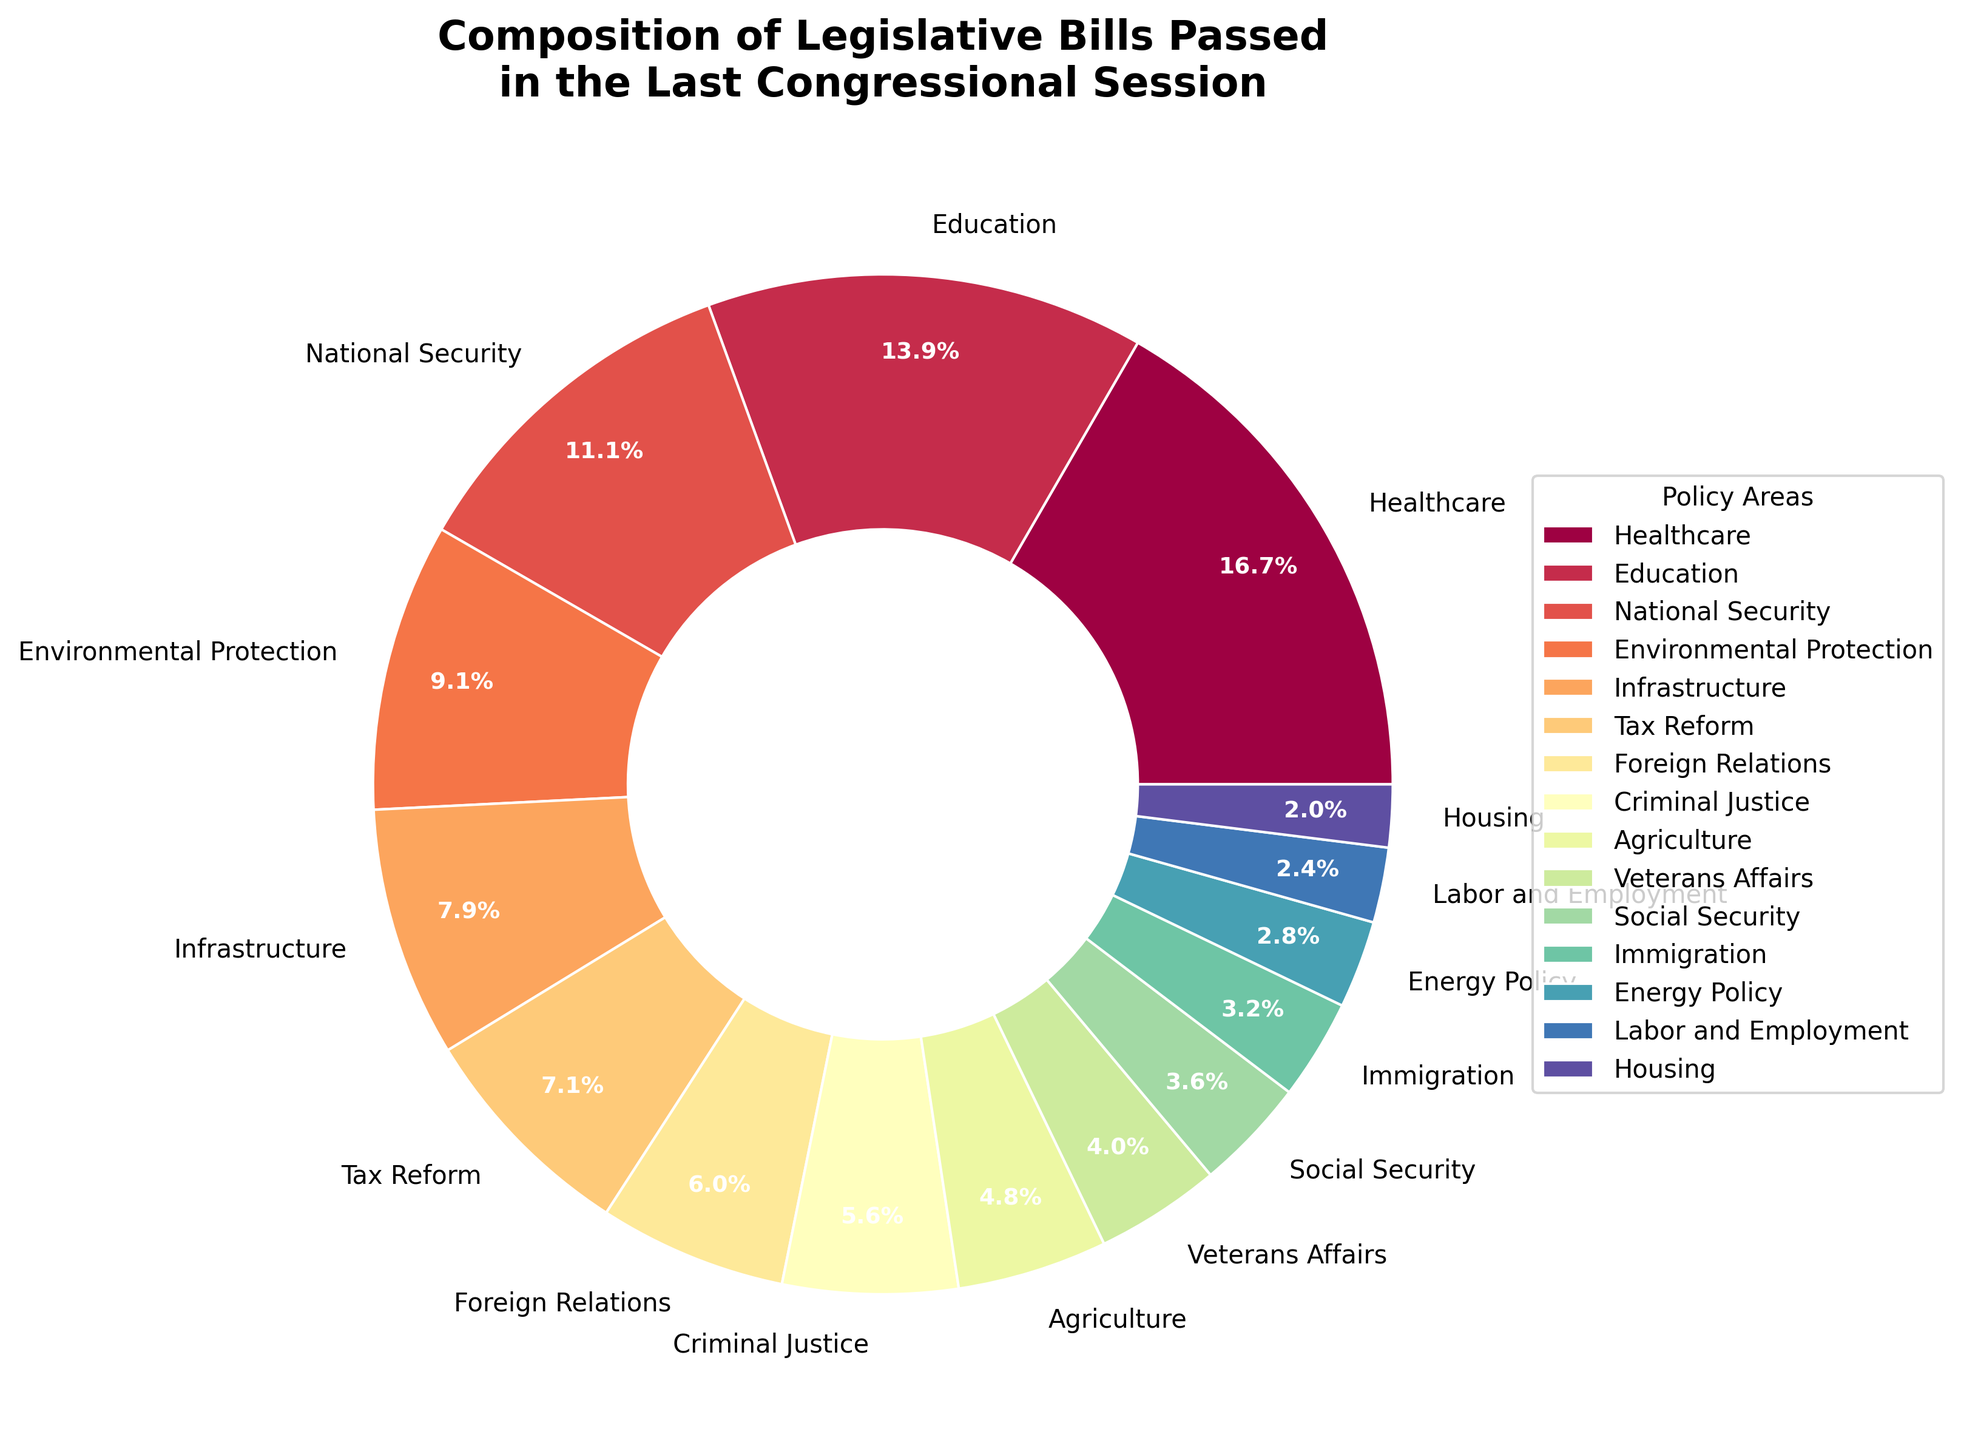What percentage of bills passed pertained to Healthcare? The slice labeled "Healthcare" on the pie chart indicates the percentage of bills related to this policy area.
Answer: 19.0% How many policy areas constitute more than 10% of the total bills passed? To identify this, look at the pie slices that represent more than 10% of the total pie. "Healthcare" (19.0%), "Education" (15.8%), and "National Security" (12.6%) make the cut.
Answer: 3 Which policy area had a higher percentage of bills passed: Environmental Protection or Infrastructure? Compare the percentages shown on the pie slices for "Environmental Protection" and "Infrastructure". "Environmental Protection" is 10.4%, while "Infrastructure" is 9.0%.
Answer: Environmental Protection What is the combined percentage of bills passed in the areas of Tax Reform and Foreign Relations? Add the percentages for "Tax Reform" (8.1%) and "Foreign Relations" (6.8%).
Answer: 14.9% Between Agriculture and Veterans Affairs, which one had fewer bills passed? Compare the pie slices for "Agriculture" and "Veterans Affairs". "Agriculture" has 5.4%, and "Veterans Affairs" has 4.5%.
Answer: Veterans Affairs How many policy areas have bills accounting for 5% or less of the total? Identify the pie slices with 5% or less. "Social Security" (4.1%), "Immigration" (3.6%), "Energy Policy" (3.2%), "Labor and Employment" (2.7%), and "Housing" (2.3%) fit this criterion.
Answer: 5 Which policy area had the least number of bills passed and what percentage does it represent? The smallest slice on the pie chart is for "Housing", which represents 2.3%.
Answer: Housing, 2.3% What is the difference in the number of bills passed between Healthcare and Education? The number of bills for Healthcare is 42, and for Education, it is 35. The difference is 42 - 35.
Answer: 7 If you combine the percentages for the top three policy areas, what is the result? Sum the percentages for the top three slices: Healthcare (19.0%), Education (15.8%), and National Security (12.6%).
Answer: 47.4% Which policy area has the slice colored closest to red? The chart uses the Spectral colormap. The top slice "Healthcare" usually would appear closest to red in this colormap.
Answer: Healthcare 